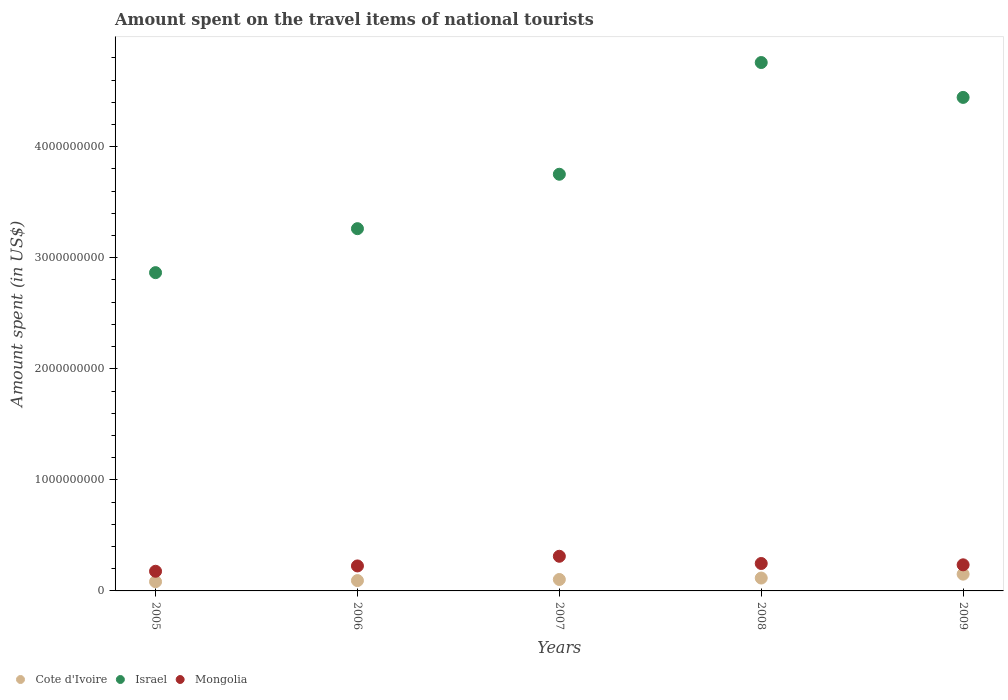How many different coloured dotlines are there?
Your response must be concise. 3. What is the amount spent on the travel items of national tourists in Cote d'Ivoire in 2007?
Your answer should be compact. 1.03e+08. Across all years, what is the maximum amount spent on the travel items of national tourists in Cote d'Ivoire?
Offer a terse response. 1.51e+08. Across all years, what is the minimum amount spent on the travel items of national tourists in Cote d'Ivoire?
Your answer should be compact. 8.30e+07. In which year was the amount spent on the travel items of national tourists in Mongolia minimum?
Provide a succinct answer. 2005. What is the total amount spent on the travel items of national tourists in Mongolia in the graph?
Your response must be concise. 1.20e+09. What is the difference between the amount spent on the travel items of national tourists in Cote d'Ivoire in 2007 and that in 2009?
Keep it short and to the point. -4.80e+07. What is the difference between the amount spent on the travel items of national tourists in Cote d'Ivoire in 2006 and the amount spent on the travel items of national tourists in Mongolia in 2008?
Give a very brief answer. -1.54e+08. What is the average amount spent on the travel items of national tourists in Mongolia per year?
Give a very brief answer. 2.39e+08. In the year 2008, what is the difference between the amount spent on the travel items of national tourists in Israel and amount spent on the travel items of national tourists in Cote d'Ivoire?
Provide a succinct answer. 4.64e+09. What is the ratio of the amount spent on the travel items of national tourists in Israel in 2005 to that in 2006?
Make the answer very short. 0.88. Is the difference between the amount spent on the travel items of national tourists in Israel in 2008 and 2009 greater than the difference between the amount spent on the travel items of national tourists in Cote d'Ivoire in 2008 and 2009?
Make the answer very short. Yes. What is the difference between the highest and the second highest amount spent on the travel items of national tourists in Israel?
Your answer should be compact. 3.14e+08. What is the difference between the highest and the lowest amount spent on the travel items of national tourists in Mongolia?
Provide a short and direct response. 1.35e+08. In how many years, is the amount spent on the travel items of national tourists in Mongolia greater than the average amount spent on the travel items of national tourists in Mongolia taken over all years?
Make the answer very short. 2. Is it the case that in every year, the sum of the amount spent on the travel items of national tourists in Cote d'Ivoire and amount spent on the travel items of national tourists in Mongolia  is greater than the amount spent on the travel items of national tourists in Israel?
Your answer should be very brief. No. Is the amount spent on the travel items of national tourists in Israel strictly greater than the amount spent on the travel items of national tourists in Cote d'Ivoire over the years?
Offer a very short reply. Yes. Is the amount spent on the travel items of national tourists in Cote d'Ivoire strictly less than the amount spent on the travel items of national tourists in Israel over the years?
Make the answer very short. Yes. How many years are there in the graph?
Provide a succinct answer. 5. Does the graph contain any zero values?
Offer a terse response. No. How are the legend labels stacked?
Make the answer very short. Horizontal. What is the title of the graph?
Offer a very short reply. Amount spent on the travel items of national tourists. Does "Canada" appear as one of the legend labels in the graph?
Your response must be concise. No. What is the label or title of the X-axis?
Keep it short and to the point. Years. What is the label or title of the Y-axis?
Offer a very short reply. Amount spent (in US$). What is the Amount spent (in US$) of Cote d'Ivoire in 2005?
Give a very brief answer. 8.30e+07. What is the Amount spent (in US$) in Israel in 2005?
Give a very brief answer. 2.87e+09. What is the Amount spent (in US$) in Mongolia in 2005?
Offer a terse response. 1.77e+08. What is the Amount spent (in US$) in Cote d'Ivoire in 2006?
Provide a short and direct response. 9.30e+07. What is the Amount spent (in US$) in Israel in 2006?
Provide a succinct answer. 3.26e+09. What is the Amount spent (in US$) of Mongolia in 2006?
Offer a very short reply. 2.25e+08. What is the Amount spent (in US$) of Cote d'Ivoire in 2007?
Your response must be concise. 1.03e+08. What is the Amount spent (in US$) in Israel in 2007?
Offer a very short reply. 3.75e+09. What is the Amount spent (in US$) of Mongolia in 2007?
Provide a short and direct response. 3.12e+08. What is the Amount spent (in US$) of Cote d'Ivoire in 2008?
Give a very brief answer. 1.16e+08. What is the Amount spent (in US$) in Israel in 2008?
Your response must be concise. 4.76e+09. What is the Amount spent (in US$) in Mongolia in 2008?
Keep it short and to the point. 2.47e+08. What is the Amount spent (in US$) of Cote d'Ivoire in 2009?
Your answer should be very brief. 1.51e+08. What is the Amount spent (in US$) in Israel in 2009?
Your answer should be very brief. 4.44e+09. What is the Amount spent (in US$) in Mongolia in 2009?
Your answer should be compact. 2.35e+08. Across all years, what is the maximum Amount spent (in US$) in Cote d'Ivoire?
Offer a terse response. 1.51e+08. Across all years, what is the maximum Amount spent (in US$) in Israel?
Your answer should be very brief. 4.76e+09. Across all years, what is the maximum Amount spent (in US$) in Mongolia?
Ensure brevity in your answer.  3.12e+08. Across all years, what is the minimum Amount spent (in US$) of Cote d'Ivoire?
Provide a short and direct response. 8.30e+07. Across all years, what is the minimum Amount spent (in US$) of Israel?
Offer a terse response. 2.87e+09. Across all years, what is the minimum Amount spent (in US$) in Mongolia?
Give a very brief answer. 1.77e+08. What is the total Amount spent (in US$) of Cote d'Ivoire in the graph?
Your response must be concise. 5.46e+08. What is the total Amount spent (in US$) in Israel in the graph?
Make the answer very short. 1.91e+1. What is the total Amount spent (in US$) of Mongolia in the graph?
Provide a succinct answer. 1.20e+09. What is the difference between the Amount spent (in US$) in Cote d'Ivoire in 2005 and that in 2006?
Ensure brevity in your answer.  -1.00e+07. What is the difference between the Amount spent (in US$) in Israel in 2005 and that in 2006?
Offer a terse response. -3.96e+08. What is the difference between the Amount spent (in US$) of Mongolia in 2005 and that in 2006?
Your answer should be compact. -4.80e+07. What is the difference between the Amount spent (in US$) in Cote d'Ivoire in 2005 and that in 2007?
Provide a short and direct response. -2.00e+07. What is the difference between the Amount spent (in US$) in Israel in 2005 and that in 2007?
Offer a very short reply. -8.86e+08. What is the difference between the Amount spent (in US$) of Mongolia in 2005 and that in 2007?
Your answer should be very brief. -1.35e+08. What is the difference between the Amount spent (in US$) of Cote d'Ivoire in 2005 and that in 2008?
Provide a short and direct response. -3.30e+07. What is the difference between the Amount spent (in US$) in Israel in 2005 and that in 2008?
Ensure brevity in your answer.  -1.89e+09. What is the difference between the Amount spent (in US$) of Mongolia in 2005 and that in 2008?
Your answer should be very brief. -7.00e+07. What is the difference between the Amount spent (in US$) in Cote d'Ivoire in 2005 and that in 2009?
Make the answer very short. -6.80e+07. What is the difference between the Amount spent (in US$) of Israel in 2005 and that in 2009?
Provide a succinct answer. -1.58e+09. What is the difference between the Amount spent (in US$) of Mongolia in 2005 and that in 2009?
Your answer should be compact. -5.80e+07. What is the difference between the Amount spent (in US$) in Cote d'Ivoire in 2006 and that in 2007?
Give a very brief answer. -1.00e+07. What is the difference between the Amount spent (in US$) of Israel in 2006 and that in 2007?
Offer a terse response. -4.90e+08. What is the difference between the Amount spent (in US$) of Mongolia in 2006 and that in 2007?
Provide a short and direct response. -8.70e+07. What is the difference between the Amount spent (in US$) of Cote d'Ivoire in 2006 and that in 2008?
Ensure brevity in your answer.  -2.30e+07. What is the difference between the Amount spent (in US$) of Israel in 2006 and that in 2008?
Your response must be concise. -1.50e+09. What is the difference between the Amount spent (in US$) in Mongolia in 2006 and that in 2008?
Your answer should be very brief. -2.20e+07. What is the difference between the Amount spent (in US$) of Cote d'Ivoire in 2006 and that in 2009?
Offer a terse response. -5.80e+07. What is the difference between the Amount spent (in US$) of Israel in 2006 and that in 2009?
Offer a terse response. -1.18e+09. What is the difference between the Amount spent (in US$) of Mongolia in 2006 and that in 2009?
Keep it short and to the point. -1.00e+07. What is the difference between the Amount spent (in US$) of Cote d'Ivoire in 2007 and that in 2008?
Make the answer very short. -1.30e+07. What is the difference between the Amount spent (in US$) in Israel in 2007 and that in 2008?
Your answer should be compact. -1.01e+09. What is the difference between the Amount spent (in US$) of Mongolia in 2007 and that in 2008?
Your response must be concise. 6.50e+07. What is the difference between the Amount spent (in US$) of Cote d'Ivoire in 2007 and that in 2009?
Provide a short and direct response. -4.80e+07. What is the difference between the Amount spent (in US$) of Israel in 2007 and that in 2009?
Your answer should be very brief. -6.92e+08. What is the difference between the Amount spent (in US$) in Mongolia in 2007 and that in 2009?
Provide a succinct answer. 7.70e+07. What is the difference between the Amount spent (in US$) of Cote d'Ivoire in 2008 and that in 2009?
Provide a short and direct response. -3.50e+07. What is the difference between the Amount spent (in US$) in Israel in 2008 and that in 2009?
Your answer should be very brief. 3.14e+08. What is the difference between the Amount spent (in US$) of Cote d'Ivoire in 2005 and the Amount spent (in US$) of Israel in 2006?
Your answer should be very brief. -3.18e+09. What is the difference between the Amount spent (in US$) of Cote d'Ivoire in 2005 and the Amount spent (in US$) of Mongolia in 2006?
Your response must be concise. -1.42e+08. What is the difference between the Amount spent (in US$) in Israel in 2005 and the Amount spent (in US$) in Mongolia in 2006?
Make the answer very short. 2.64e+09. What is the difference between the Amount spent (in US$) in Cote d'Ivoire in 2005 and the Amount spent (in US$) in Israel in 2007?
Provide a short and direct response. -3.67e+09. What is the difference between the Amount spent (in US$) of Cote d'Ivoire in 2005 and the Amount spent (in US$) of Mongolia in 2007?
Your answer should be very brief. -2.29e+08. What is the difference between the Amount spent (in US$) of Israel in 2005 and the Amount spent (in US$) of Mongolia in 2007?
Keep it short and to the point. 2.55e+09. What is the difference between the Amount spent (in US$) in Cote d'Ivoire in 2005 and the Amount spent (in US$) in Israel in 2008?
Your answer should be compact. -4.68e+09. What is the difference between the Amount spent (in US$) in Cote d'Ivoire in 2005 and the Amount spent (in US$) in Mongolia in 2008?
Your answer should be very brief. -1.64e+08. What is the difference between the Amount spent (in US$) of Israel in 2005 and the Amount spent (in US$) of Mongolia in 2008?
Provide a short and direct response. 2.62e+09. What is the difference between the Amount spent (in US$) of Cote d'Ivoire in 2005 and the Amount spent (in US$) of Israel in 2009?
Your answer should be very brief. -4.36e+09. What is the difference between the Amount spent (in US$) of Cote d'Ivoire in 2005 and the Amount spent (in US$) of Mongolia in 2009?
Provide a short and direct response. -1.52e+08. What is the difference between the Amount spent (in US$) of Israel in 2005 and the Amount spent (in US$) of Mongolia in 2009?
Offer a very short reply. 2.63e+09. What is the difference between the Amount spent (in US$) in Cote d'Ivoire in 2006 and the Amount spent (in US$) in Israel in 2007?
Keep it short and to the point. -3.66e+09. What is the difference between the Amount spent (in US$) of Cote d'Ivoire in 2006 and the Amount spent (in US$) of Mongolia in 2007?
Ensure brevity in your answer.  -2.19e+08. What is the difference between the Amount spent (in US$) of Israel in 2006 and the Amount spent (in US$) of Mongolia in 2007?
Keep it short and to the point. 2.95e+09. What is the difference between the Amount spent (in US$) of Cote d'Ivoire in 2006 and the Amount spent (in US$) of Israel in 2008?
Keep it short and to the point. -4.66e+09. What is the difference between the Amount spent (in US$) in Cote d'Ivoire in 2006 and the Amount spent (in US$) in Mongolia in 2008?
Give a very brief answer. -1.54e+08. What is the difference between the Amount spent (in US$) in Israel in 2006 and the Amount spent (in US$) in Mongolia in 2008?
Make the answer very short. 3.02e+09. What is the difference between the Amount spent (in US$) in Cote d'Ivoire in 2006 and the Amount spent (in US$) in Israel in 2009?
Give a very brief answer. -4.35e+09. What is the difference between the Amount spent (in US$) in Cote d'Ivoire in 2006 and the Amount spent (in US$) in Mongolia in 2009?
Make the answer very short. -1.42e+08. What is the difference between the Amount spent (in US$) of Israel in 2006 and the Amount spent (in US$) of Mongolia in 2009?
Your answer should be very brief. 3.03e+09. What is the difference between the Amount spent (in US$) in Cote d'Ivoire in 2007 and the Amount spent (in US$) in Israel in 2008?
Your answer should be compact. -4.66e+09. What is the difference between the Amount spent (in US$) in Cote d'Ivoire in 2007 and the Amount spent (in US$) in Mongolia in 2008?
Ensure brevity in your answer.  -1.44e+08. What is the difference between the Amount spent (in US$) in Israel in 2007 and the Amount spent (in US$) in Mongolia in 2008?
Offer a terse response. 3.50e+09. What is the difference between the Amount spent (in US$) in Cote d'Ivoire in 2007 and the Amount spent (in US$) in Israel in 2009?
Ensure brevity in your answer.  -4.34e+09. What is the difference between the Amount spent (in US$) in Cote d'Ivoire in 2007 and the Amount spent (in US$) in Mongolia in 2009?
Keep it short and to the point. -1.32e+08. What is the difference between the Amount spent (in US$) in Israel in 2007 and the Amount spent (in US$) in Mongolia in 2009?
Give a very brief answer. 3.52e+09. What is the difference between the Amount spent (in US$) in Cote d'Ivoire in 2008 and the Amount spent (in US$) in Israel in 2009?
Provide a succinct answer. -4.33e+09. What is the difference between the Amount spent (in US$) in Cote d'Ivoire in 2008 and the Amount spent (in US$) in Mongolia in 2009?
Give a very brief answer. -1.19e+08. What is the difference between the Amount spent (in US$) of Israel in 2008 and the Amount spent (in US$) of Mongolia in 2009?
Offer a terse response. 4.52e+09. What is the average Amount spent (in US$) in Cote d'Ivoire per year?
Give a very brief answer. 1.09e+08. What is the average Amount spent (in US$) in Israel per year?
Your answer should be compact. 3.82e+09. What is the average Amount spent (in US$) in Mongolia per year?
Your response must be concise. 2.39e+08. In the year 2005, what is the difference between the Amount spent (in US$) of Cote d'Ivoire and Amount spent (in US$) of Israel?
Offer a terse response. -2.78e+09. In the year 2005, what is the difference between the Amount spent (in US$) of Cote d'Ivoire and Amount spent (in US$) of Mongolia?
Your answer should be compact. -9.40e+07. In the year 2005, what is the difference between the Amount spent (in US$) in Israel and Amount spent (in US$) in Mongolia?
Make the answer very short. 2.69e+09. In the year 2006, what is the difference between the Amount spent (in US$) in Cote d'Ivoire and Amount spent (in US$) in Israel?
Offer a terse response. -3.17e+09. In the year 2006, what is the difference between the Amount spent (in US$) of Cote d'Ivoire and Amount spent (in US$) of Mongolia?
Your answer should be very brief. -1.32e+08. In the year 2006, what is the difference between the Amount spent (in US$) of Israel and Amount spent (in US$) of Mongolia?
Your response must be concise. 3.04e+09. In the year 2007, what is the difference between the Amount spent (in US$) in Cote d'Ivoire and Amount spent (in US$) in Israel?
Provide a succinct answer. -3.65e+09. In the year 2007, what is the difference between the Amount spent (in US$) in Cote d'Ivoire and Amount spent (in US$) in Mongolia?
Your answer should be very brief. -2.09e+08. In the year 2007, what is the difference between the Amount spent (in US$) in Israel and Amount spent (in US$) in Mongolia?
Offer a very short reply. 3.44e+09. In the year 2008, what is the difference between the Amount spent (in US$) of Cote d'Ivoire and Amount spent (in US$) of Israel?
Ensure brevity in your answer.  -4.64e+09. In the year 2008, what is the difference between the Amount spent (in US$) in Cote d'Ivoire and Amount spent (in US$) in Mongolia?
Make the answer very short. -1.31e+08. In the year 2008, what is the difference between the Amount spent (in US$) of Israel and Amount spent (in US$) of Mongolia?
Give a very brief answer. 4.51e+09. In the year 2009, what is the difference between the Amount spent (in US$) in Cote d'Ivoire and Amount spent (in US$) in Israel?
Ensure brevity in your answer.  -4.29e+09. In the year 2009, what is the difference between the Amount spent (in US$) in Cote d'Ivoire and Amount spent (in US$) in Mongolia?
Make the answer very short. -8.40e+07. In the year 2009, what is the difference between the Amount spent (in US$) of Israel and Amount spent (in US$) of Mongolia?
Give a very brief answer. 4.21e+09. What is the ratio of the Amount spent (in US$) of Cote d'Ivoire in 2005 to that in 2006?
Your response must be concise. 0.89. What is the ratio of the Amount spent (in US$) in Israel in 2005 to that in 2006?
Provide a short and direct response. 0.88. What is the ratio of the Amount spent (in US$) in Mongolia in 2005 to that in 2006?
Offer a very short reply. 0.79. What is the ratio of the Amount spent (in US$) of Cote d'Ivoire in 2005 to that in 2007?
Offer a terse response. 0.81. What is the ratio of the Amount spent (in US$) in Israel in 2005 to that in 2007?
Your answer should be compact. 0.76. What is the ratio of the Amount spent (in US$) in Mongolia in 2005 to that in 2007?
Provide a short and direct response. 0.57. What is the ratio of the Amount spent (in US$) in Cote d'Ivoire in 2005 to that in 2008?
Give a very brief answer. 0.72. What is the ratio of the Amount spent (in US$) of Israel in 2005 to that in 2008?
Keep it short and to the point. 0.6. What is the ratio of the Amount spent (in US$) of Mongolia in 2005 to that in 2008?
Offer a terse response. 0.72. What is the ratio of the Amount spent (in US$) in Cote d'Ivoire in 2005 to that in 2009?
Ensure brevity in your answer.  0.55. What is the ratio of the Amount spent (in US$) in Israel in 2005 to that in 2009?
Provide a short and direct response. 0.64. What is the ratio of the Amount spent (in US$) of Mongolia in 2005 to that in 2009?
Ensure brevity in your answer.  0.75. What is the ratio of the Amount spent (in US$) of Cote d'Ivoire in 2006 to that in 2007?
Offer a terse response. 0.9. What is the ratio of the Amount spent (in US$) of Israel in 2006 to that in 2007?
Your answer should be compact. 0.87. What is the ratio of the Amount spent (in US$) of Mongolia in 2006 to that in 2007?
Keep it short and to the point. 0.72. What is the ratio of the Amount spent (in US$) in Cote d'Ivoire in 2006 to that in 2008?
Provide a short and direct response. 0.8. What is the ratio of the Amount spent (in US$) of Israel in 2006 to that in 2008?
Offer a very short reply. 0.69. What is the ratio of the Amount spent (in US$) in Mongolia in 2006 to that in 2008?
Make the answer very short. 0.91. What is the ratio of the Amount spent (in US$) of Cote d'Ivoire in 2006 to that in 2009?
Keep it short and to the point. 0.62. What is the ratio of the Amount spent (in US$) in Israel in 2006 to that in 2009?
Provide a succinct answer. 0.73. What is the ratio of the Amount spent (in US$) in Mongolia in 2006 to that in 2009?
Offer a terse response. 0.96. What is the ratio of the Amount spent (in US$) in Cote d'Ivoire in 2007 to that in 2008?
Give a very brief answer. 0.89. What is the ratio of the Amount spent (in US$) in Israel in 2007 to that in 2008?
Your response must be concise. 0.79. What is the ratio of the Amount spent (in US$) in Mongolia in 2007 to that in 2008?
Give a very brief answer. 1.26. What is the ratio of the Amount spent (in US$) of Cote d'Ivoire in 2007 to that in 2009?
Your response must be concise. 0.68. What is the ratio of the Amount spent (in US$) of Israel in 2007 to that in 2009?
Offer a very short reply. 0.84. What is the ratio of the Amount spent (in US$) in Mongolia in 2007 to that in 2009?
Keep it short and to the point. 1.33. What is the ratio of the Amount spent (in US$) in Cote d'Ivoire in 2008 to that in 2009?
Keep it short and to the point. 0.77. What is the ratio of the Amount spent (in US$) of Israel in 2008 to that in 2009?
Keep it short and to the point. 1.07. What is the ratio of the Amount spent (in US$) of Mongolia in 2008 to that in 2009?
Keep it short and to the point. 1.05. What is the difference between the highest and the second highest Amount spent (in US$) in Cote d'Ivoire?
Your answer should be very brief. 3.50e+07. What is the difference between the highest and the second highest Amount spent (in US$) of Israel?
Keep it short and to the point. 3.14e+08. What is the difference between the highest and the second highest Amount spent (in US$) of Mongolia?
Ensure brevity in your answer.  6.50e+07. What is the difference between the highest and the lowest Amount spent (in US$) of Cote d'Ivoire?
Provide a short and direct response. 6.80e+07. What is the difference between the highest and the lowest Amount spent (in US$) in Israel?
Your answer should be compact. 1.89e+09. What is the difference between the highest and the lowest Amount spent (in US$) of Mongolia?
Offer a very short reply. 1.35e+08. 